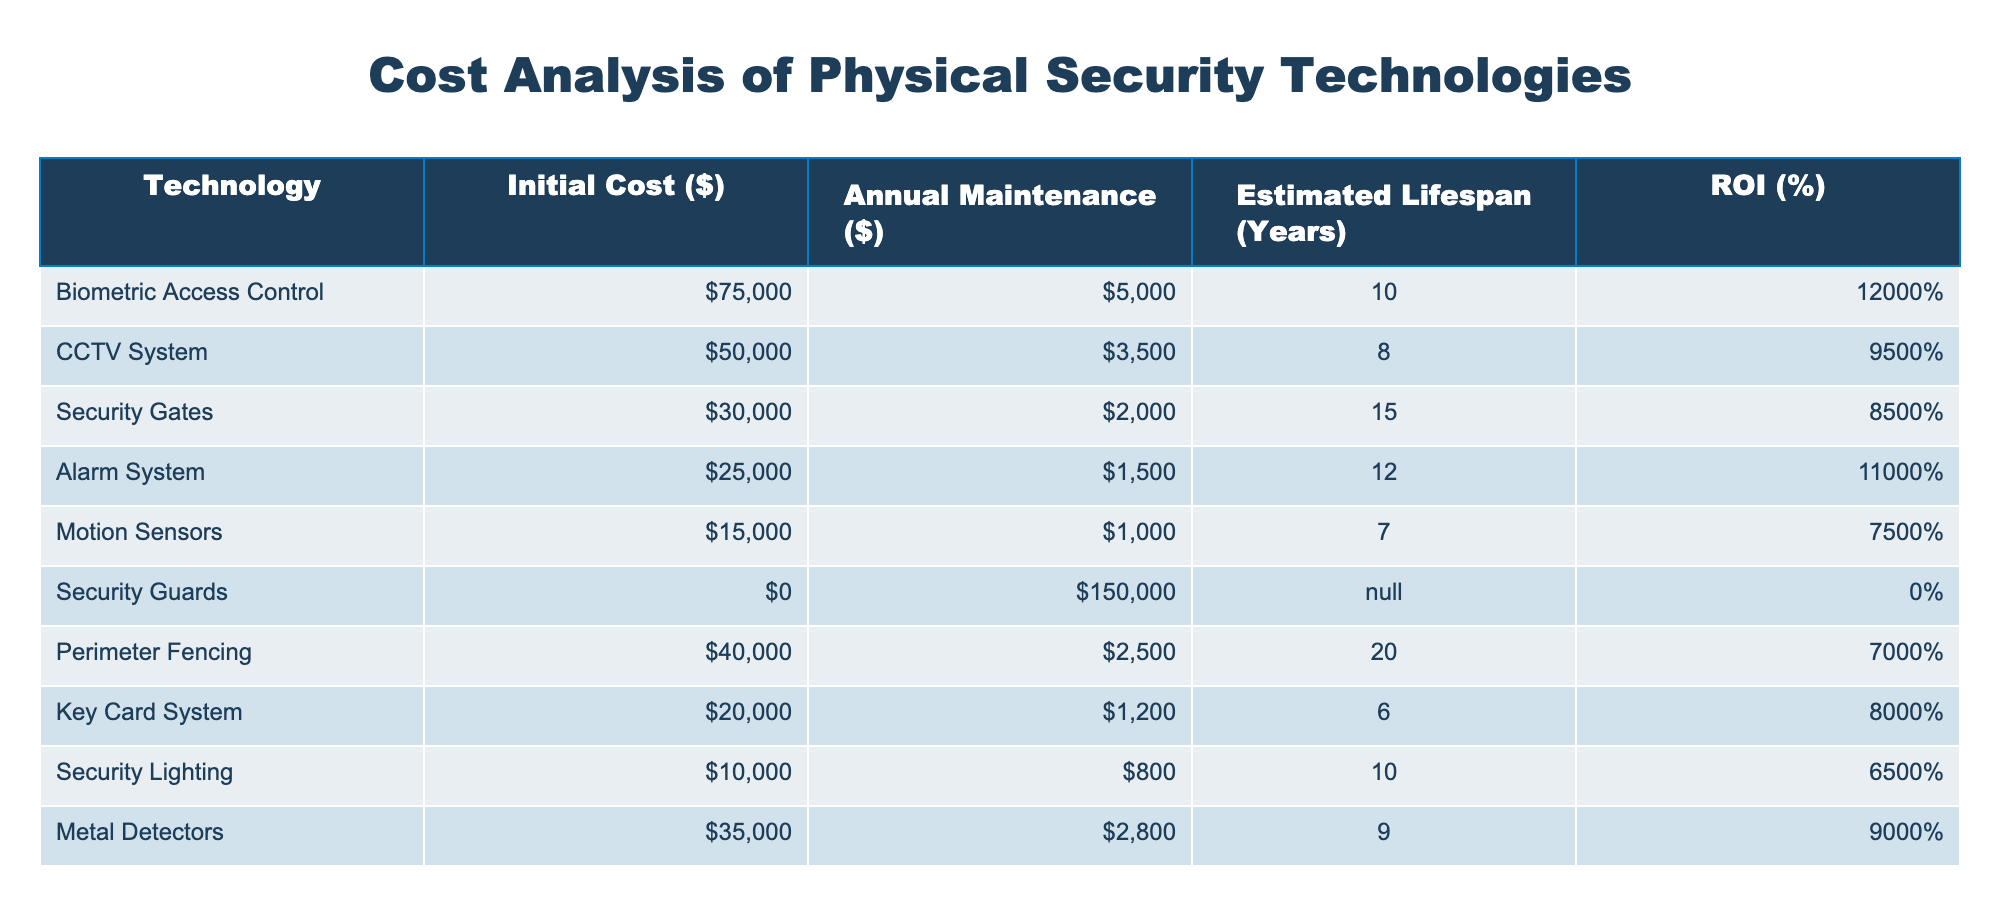What is the initial cost of the Biometric Access Control technology? The table directly lists the initial cost of Biometric Access Control as 75,000 dollars.
Answer: 75,000 What is the estimated lifespan of the Motion Sensors? According to the table, the estimated lifespan of the Motion Sensors is 7 years.
Answer: 7 years Which technology has the highest ROI percentage? By evaluating the ROI percentages listed for each technology, Biometric Access Control shows the highest ROI at 120 percent.
Answer: 120% What is the total annual maintenance cost for the CCTV System and Alarm System combined? The annual maintenance cost for the CCTV System is 3,500 dollars, and for the Alarm System, it is 1,500 dollars. Adding these together gives 3,500 + 1,500 = 5,000 dollars.
Answer: 5,000 Is the initial cost of Security Guards higher than all other listed technologies? The initial cost of Security Guards is 0 dollars, which is lower than all other technologies listed, hence the answer is no.
Answer: No What is the average estimated lifespan of the technologies listed? The estimated lifespans of all technologies are 10, 8, 15, 12, 7, 'N/A', 20, 6, 10, and 9 years, excluding Security Guards, the total calculated lifespan is 10 + 8 + 15 + 12 + 7 + 20 + 6 + 10 + 9 = 97 years, with 9 technologies gives an average of 97 / 9 ≈ 10.78 years.
Answer: Approximately 10.78 years Which technology provides the lowest annual maintenance cost? The table indicates that Motion Sensors have the lowest annual maintenance cost at 1,000 dollars.
Answer: 1,000 What are the total costs (initial cost + total maintenance cost over lifespan) for the Perimeter Fencing technology? The initial cost is 40,000 dollars, and the total maintenance cost over its 20-year lifespan is 20 years * 2,500 dollars = 50,000 dollars, thus the total cost is 40,000 + 50,000 = 90,000 dollars.
Answer: 90,000 Is the ROI of the Key Card System above or below 80 percent? The table lists the ROI of the Key Card System as 80 percent, which means it is equal to, not above or below.
Answer: No, it is equal to 80 percent 